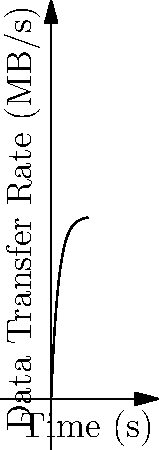As a Delphi developer working on email-related coding, you're analyzing the acceleration of data transfer rates over time. The graph shows the data transfer rate (in MB/s) as a function of time (in seconds). If the curve follows the equation $R(t) = 50(1-e^{-0.5t})$, where $R$ is the transfer rate and $t$ is time, calculate the acceleration of the data transfer rate at point A (t = 2s). To find the acceleration of the data transfer rate, we need to calculate the second derivative of the rate function with respect to time. Let's proceed step-by-step:

1) The given function for the data transfer rate is:
   $R(t) = 50(1-e^{-0.5t})$

2) First, let's find the velocity (first derivative) of the transfer rate:
   $\frac{dR}{dt} = 50 \cdot 0.5e^{-0.5t} = 25e^{-0.5t}$

3) Now, let's find the acceleration (second derivative) of the transfer rate:
   $\frac{d^2R}{dt^2} = 25 \cdot (-0.5)e^{-0.5t} = -12.5e^{-0.5t}$

4) To find the acceleration at point A (t = 2s), we substitute t = 2 into our acceleration function:
   $\frac{d^2R}{dt^2}|_{t=2} = -12.5e^{-0.5(2)} = -12.5e^{-1} \approx -4.60 \text{ MB/s}^2$

Thus, the acceleration of the data transfer rate at point A (t = 2s) is approximately -4.60 MB/s².
Answer: $-4.60 \text{ MB/s}^2$ 